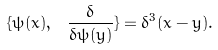Convert formula to latex. <formula><loc_0><loc_0><loc_500><loc_500>\{ \psi ( x ) , \ \frac { \delta } { \delta \psi ( y ) } \} = \delta ^ { 3 } ( x - y ) .</formula> 